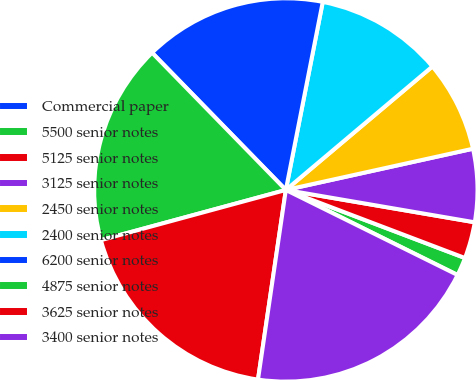Convert chart. <chart><loc_0><loc_0><loc_500><loc_500><pie_chart><fcel>Commercial paper<fcel>5500 senior notes<fcel>5125 senior notes<fcel>3125 senior notes<fcel>2450 senior notes<fcel>2400 senior notes<fcel>6200 senior notes<fcel>4875 senior notes<fcel>3625 senior notes<fcel>3400 senior notes<nl><fcel>0.0%<fcel>1.54%<fcel>3.08%<fcel>6.15%<fcel>7.69%<fcel>10.77%<fcel>15.38%<fcel>16.92%<fcel>18.46%<fcel>20.0%<nl></chart> 